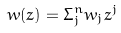<formula> <loc_0><loc_0><loc_500><loc_500>w ( z ) = \Sigma _ { j } ^ { n } w _ { j } z ^ { j }</formula> 